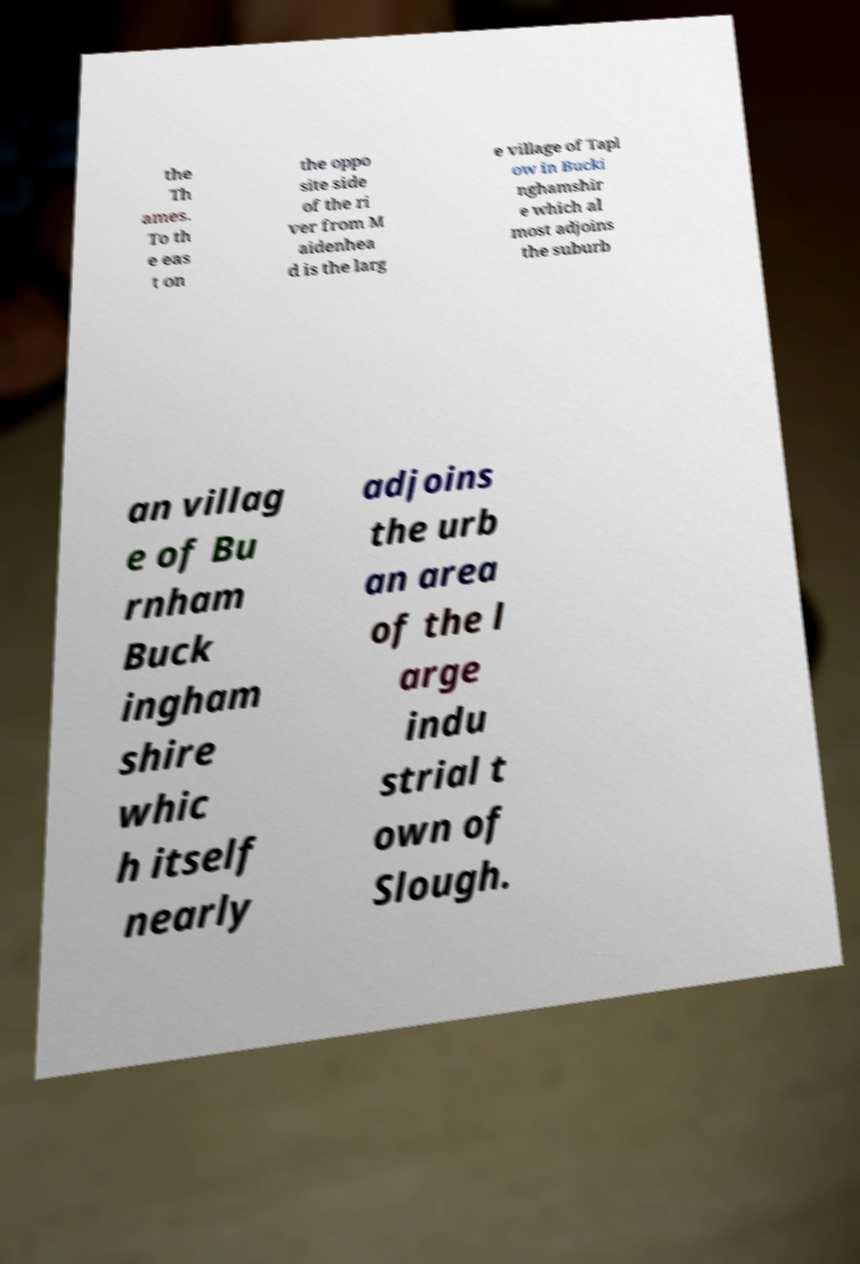Please read and relay the text visible in this image. What does it say? the Th ames. To th e eas t on the oppo site side of the ri ver from M aidenhea d is the larg e village of Tapl ow in Bucki nghamshir e which al most adjoins the suburb an villag e of Bu rnham Buck ingham shire whic h itself nearly adjoins the urb an area of the l arge indu strial t own of Slough. 